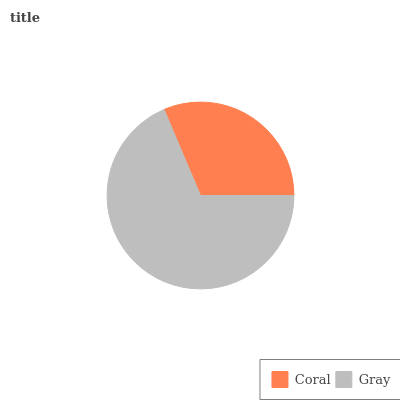Is Coral the minimum?
Answer yes or no. Yes. Is Gray the maximum?
Answer yes or no. Yes. Is Gray the minimum?
Answer yes or no. No. Is Gray greater than Coral?
Answer yes or no. Yes. Is Coral less than Gray?
Answer yes or no. Yes. Is Coral greater than Gray?
Answer yes or no. No. Is Gray less than Coral?
Answer yes or no. No. Is Gray the high median?
Answer yes or no. Yes. Is Coral the low median?
Answer yes or no. Yes. Is Coral the high median?
Answer yes or no. No. Is Gray the low median?
Answer yes or no. No. 